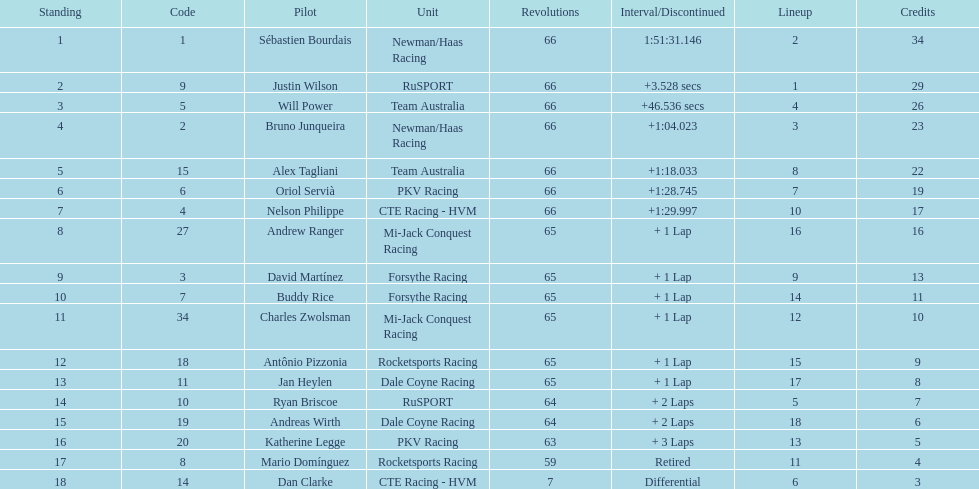In the 2006 gran premio telmex, what was the number of drivers who finished fewer than 60 laps? 2. 